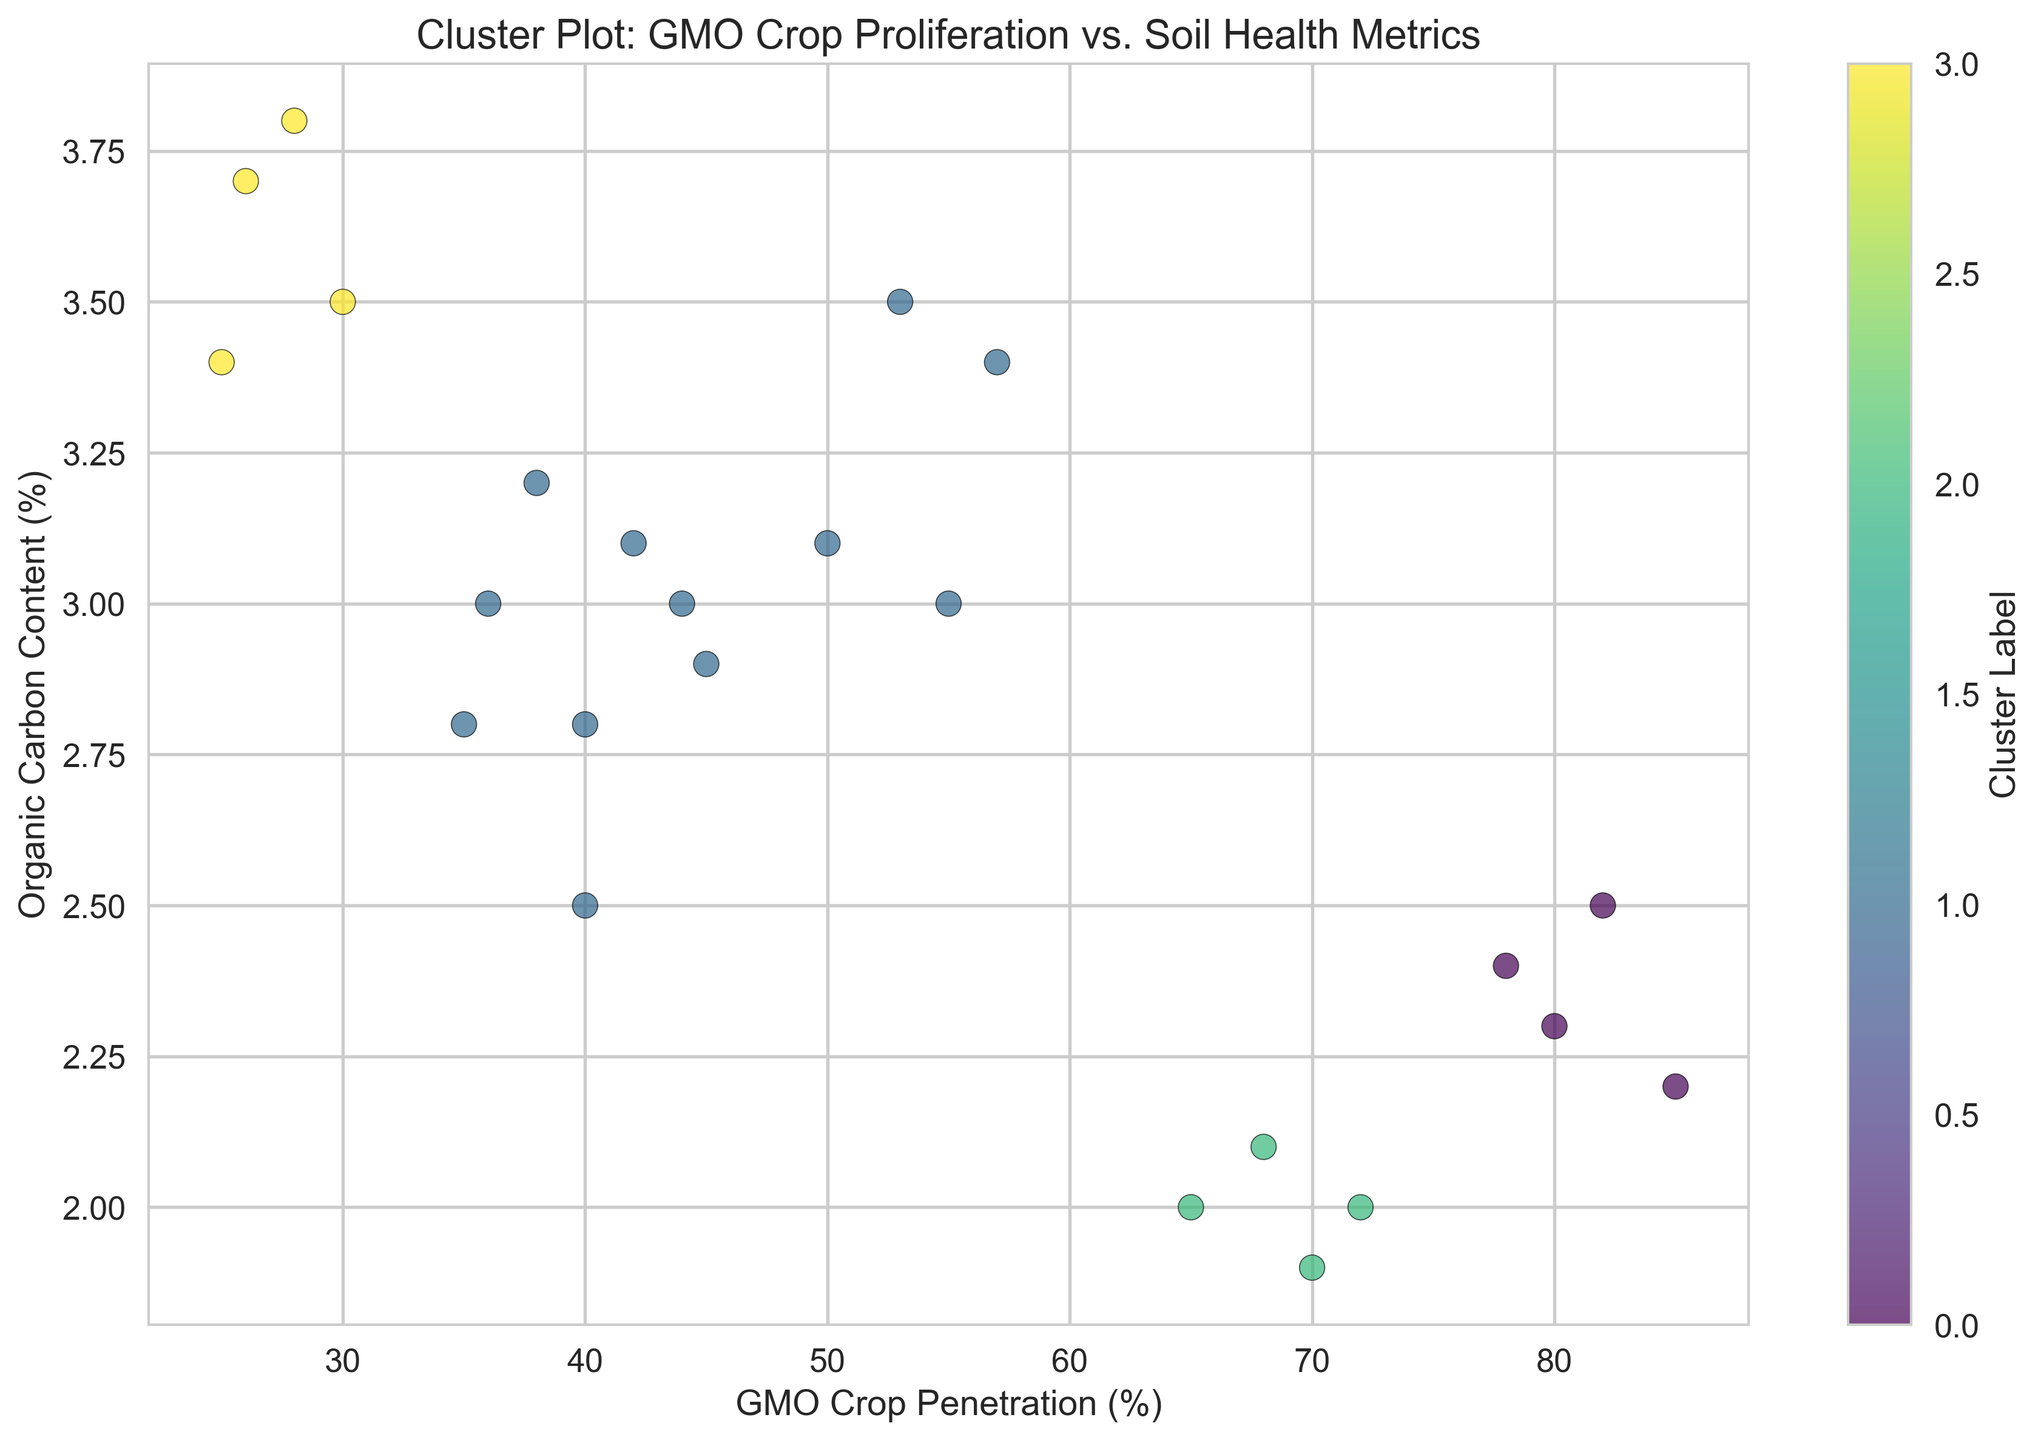What regions display the highest levels of GMO crop penetration? By examining the clustering figure, we can see that the regions with the highest levels of GMO crop penetration are those data points closer to the far right of the horizontal axis representing GMO crop penetration. The regions are those associated with the "Southwest" (with GMO penetration values around 80-85).
Answer: Southwest What is the relationship between organic carbon content and GMO crop penetration based on clusters? Looking at the figure, we can see the spread of different clusters. Points with higher GMO crop penetration (around 60-85%) tend to be in clusters where organic carbon content is lower (approximately 2.0-2.5%). Conversely, points with lower GMO crop penetration (around 25-40%) tend to have higher organic carbon content (approximately 3.0-3.8%).
Answer: Negative correlation Which cluster shows the highest organic carbon content on average? To answer this, we need to visually identify points with high organic carbon content (greater than 3.0) and observe their cluster label. The cluster with data points situated between 3.0 and 3.8 in organic carbon content has the highest organic carbon content. These points appear to be in a specific cluster labeled distinctly by color.
Answer: Cluster with high organic carbon content values How does GMO crop penetration vary within the same cluster? By observing the spread of data points within the same colored cluster, we can see that some clusters have a wide range of GMO crop penetration values; for example, one of the clusters has points ranging from about 25% up to about 45% GMO crop penetration.
Answer: Varies within 25-45% Which cluster is the most spread out in terms of GMO crop penetration values? This can be determined by identifying the cluster where the data points are spread farthest horizontally. One of the clusters appears to stretch from roughly 25% to 80% GMO crop penetration, suggesting broader variability.
Answer: Cluster with the widest horizontal spread Is there a region with clusters close together in terms of GMO crop penetration and organic carbon content? By looking at clusters, it can be observed that some clusters have tightly packed points, notably the one with GMO crop penetration values around 40-45% and organic carbon content around 2.8-3.0%. This can be seen as a tight cluster in the plot.
Answer: Yes, center-right clusters Do regions with high biodiversity indices also show low GMO crop penetration? Observing the cluster plot, points that are positioned with high biodiversity indices (greater than 0.90) are generally associated with lower GMO crop penetration (below 40%). This relationship implies that high biodiversity correlates with lower GMO crop usage.
Answer: Yes, generally What regions are primarily associated with clusters that have higher organic carbon content? Points with higher organic carbon content (above 3.0%) are mostly associated with the "Northeast" and "Midwest" regions. This can be inferred from the position of points along the vertical axis (organic carbon content) and their corresponding region labels.
Answer: Northeast and Midwest 